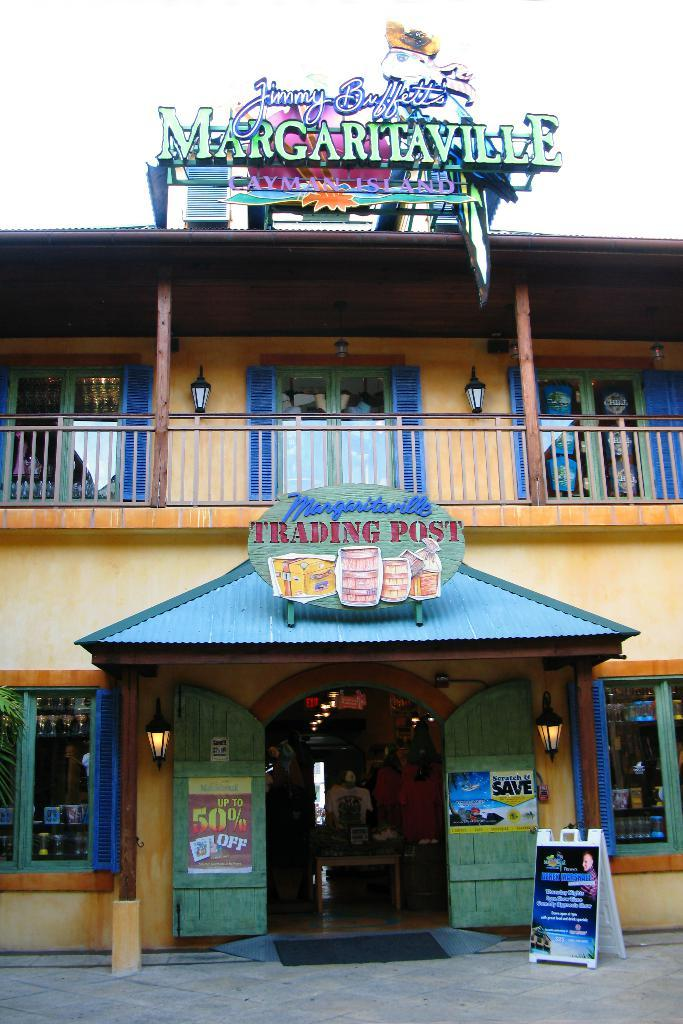<image>
Share a concise interpretation of the image provided. The establishment is called Margaritaville and offers up to 50% off. 